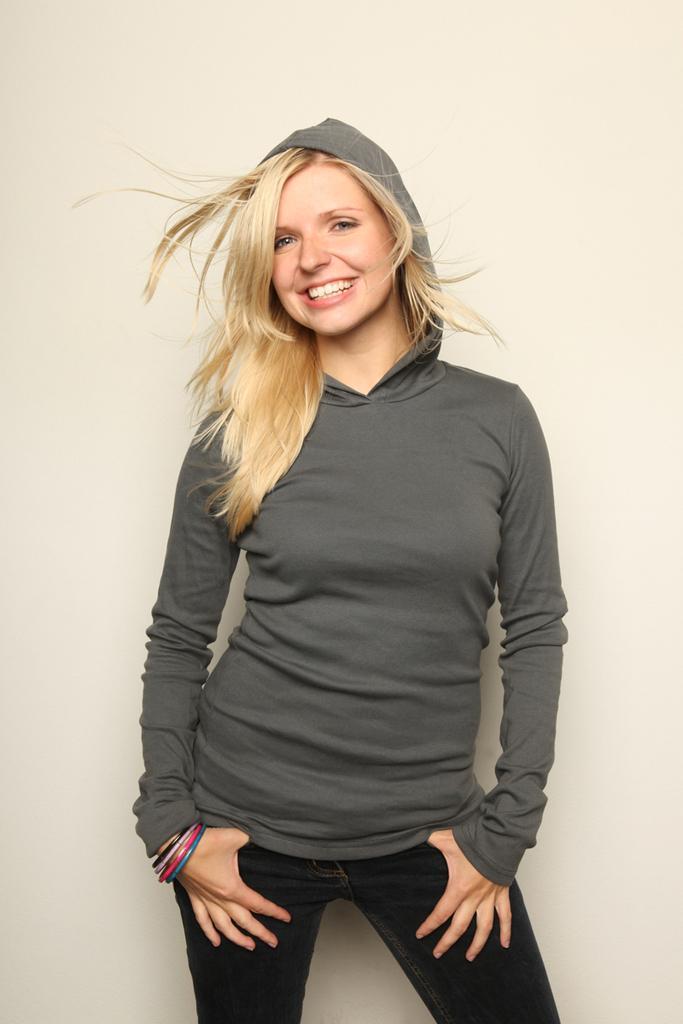How would you summarize this image in a sentence or two? In this image we can see a lady person wearing grey color hoodie, black color pant standing and posing for a photograph. 